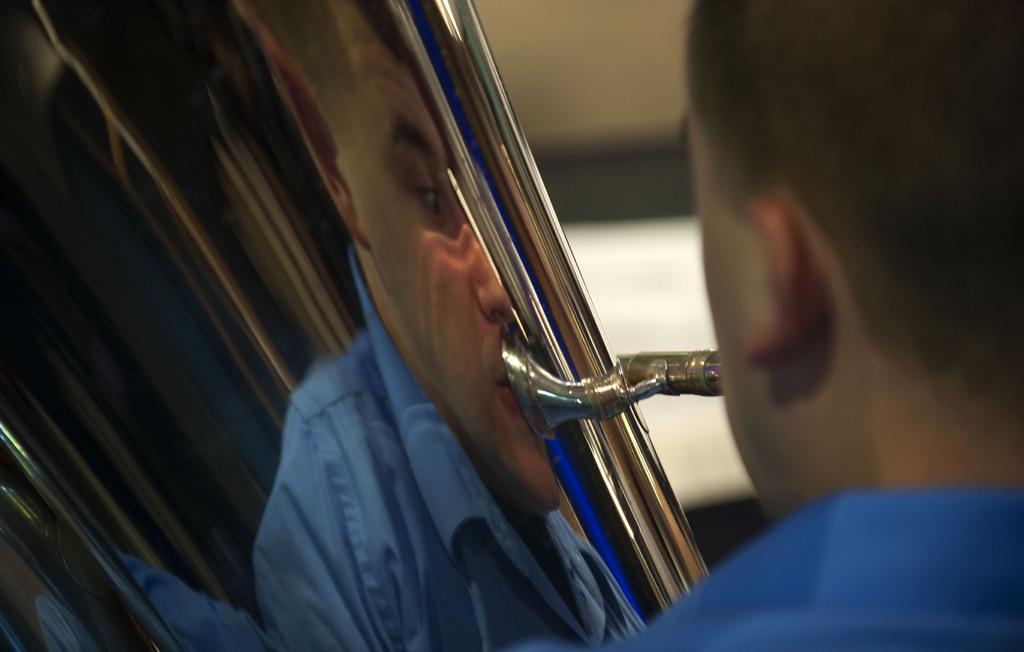Can you describe this image briefly? In this image there is a person playing a trumpet. 